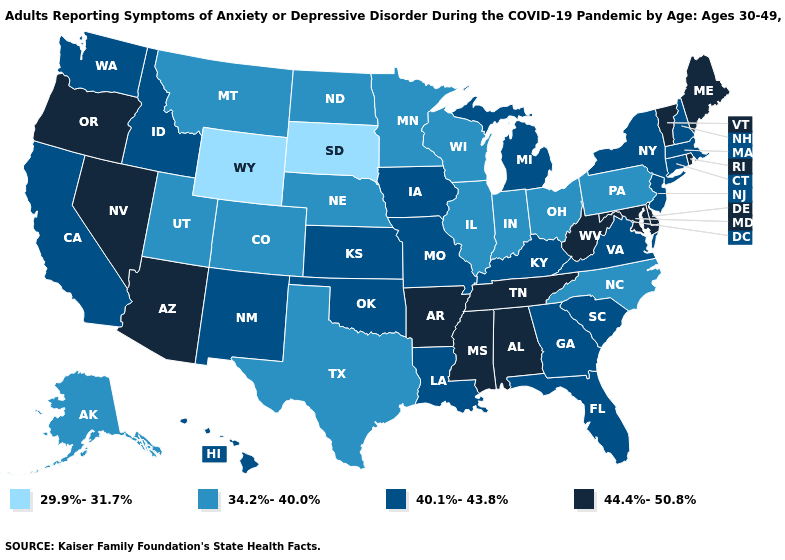Does Iowa have the highest value in the MidWest?
Quick response, please. Yes. Does the first symbol in the legend represent the smallest category?
Concise answer only. Yes. What is the highest value in the USA?
Be succinct. 44.4%-50.8%. Among the states that border Connecticut , which have the lowest value?
Write a very short answer. Massachusetts, New York. What is the value of Oregon?
Give a very brief answer. 44.4%-50.8%. What is the value of New Jersey?
Concise answer only. 40.1%-43.8%. Does Washington have the highest value in the USA?
Write a very short answer. No. Which states hav the highest value in the Northeast?
Give a very brief answer. Maine, Rhode Island, Vermont. Is the legend a continuous bar?
Answer briefly. No. What is the lowest value in states that border Wisconsin?
Write a very short answer. 34.2%-40.0%. What is the highest value in states that border Colorado?
Write a very short answer. 44.4%-50.8%. Name the states that have a value in the range 29.9%-31.7%?
Answer briefly. South Dakota, Wyoming. Name the states that have a value in the range 29.9%-31.7%?
Give a very brief answer. South Dakota, Wyoming. What is the value of Nebraska?
Quick response, please. 34.2%-40.0%. 